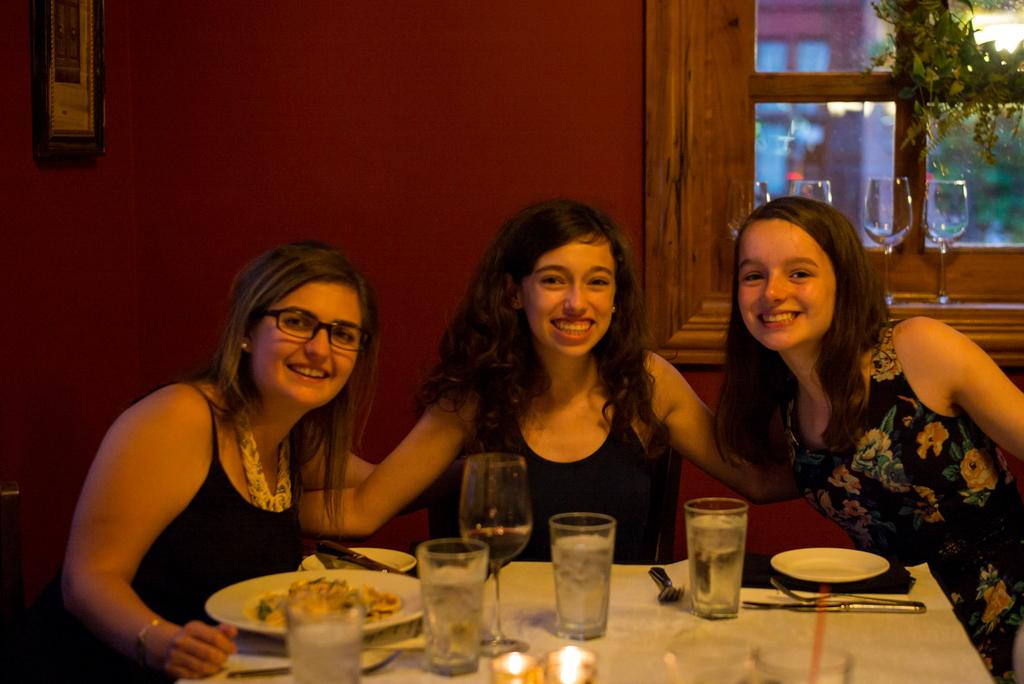How many women are in the image? There are three women in the image. What are the women doing in the image? The women are seated and smiling. What objects can be seen on the table in the image? There are plates, glasses, forks, and knives on the table. What is present on the wall in the image? There is a plant and a photo frame on the wall. What year is depicted in the photo frame on the wall? There is no information about the year in the photo frame, as it is not mentioned in the provided facts. What type of pleasure is being experienced by the women in the image? The provided facts do not mention any specific pleasure being experienced by the women; they are simply smiling. 